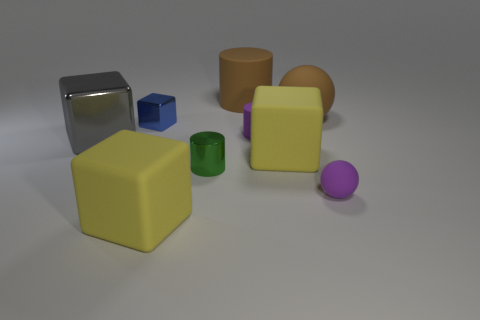What number of things are big yellow cubes or rubber things that are behind the purple rubber sphere?
Provide a short and direct response. 5. Is there a large red cube that has the same material as the blue thing?
Offer a very short reply. No. How many purple matte things are both in front of the big gray metallic cube and behind the small purple ball?
Provide a succinct answer. 0. What is the large thing left of the tiny blue thing made of?
Your answer should be very brief. Metal. There is a brown cylinder that is the same material as the purple ball; what is its size?
Your answer should be very brief. Large. Are there any tiny matte cylinders behind the big brown matte sphere?
Keep it short and to the point. No. What is the size of the other metal object that is the same shape as the gray metal object?
Give a very brief answer. Small. Is the color of the large ball the same as the tiny cylinder that is behind the big gray object?
Give a very brief answer. No. Is the tiny ball the same color as the big cylinder?
Keep it short and to the point. No. Are there fewer big matte cylinders than tiny cylinders?
Your answer should be compact. Yes. 